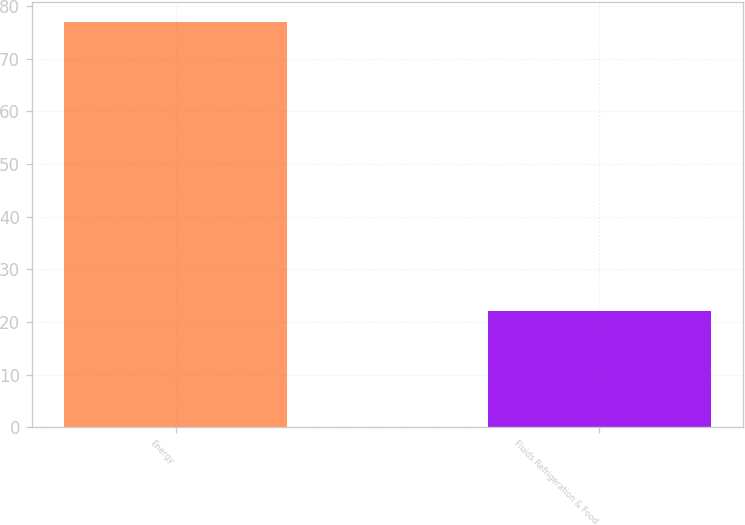<chart> <loc_0><loc_0><loc_500><loc_500><bar_chart><fcel>Energy<fcel>Fluids Refrigeration & Food<nl><fcel>77<fcel>22<nl></chart> 